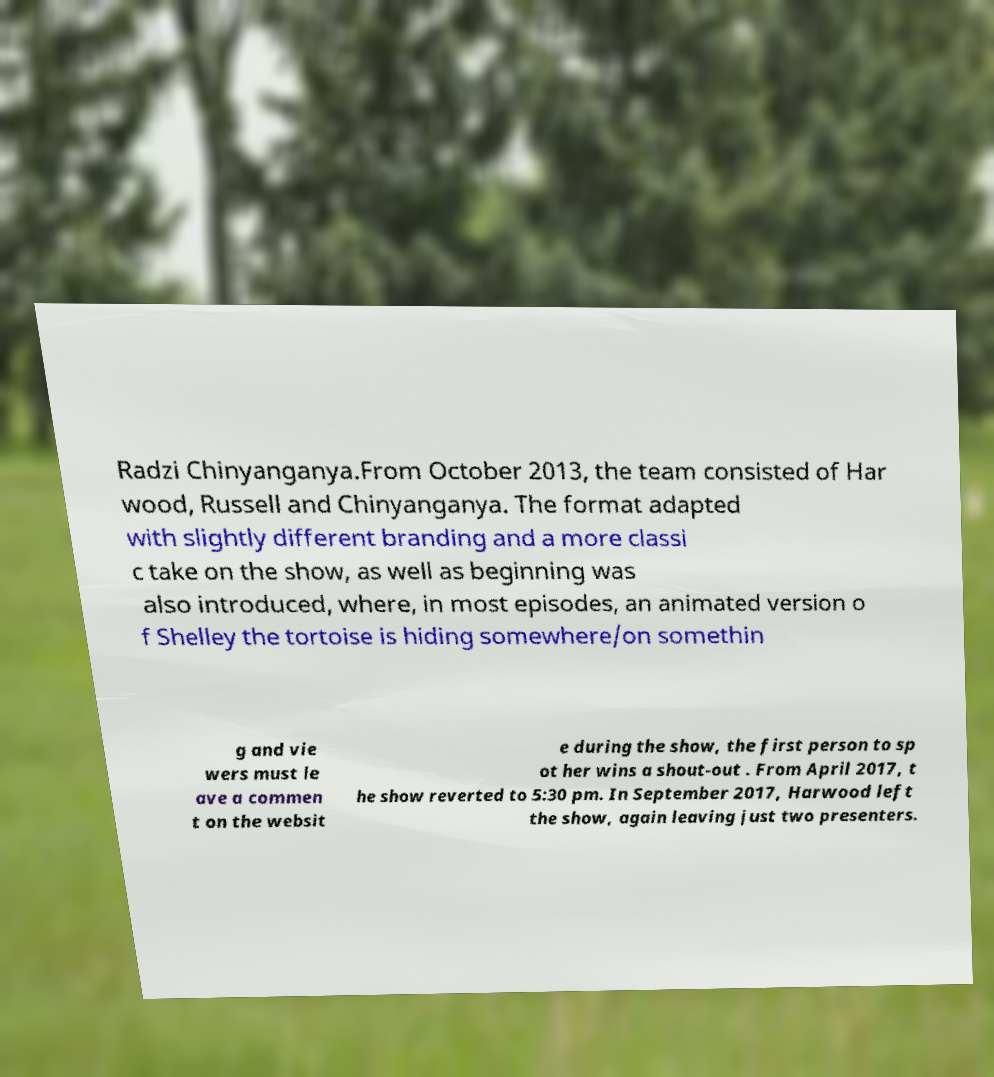Could you assist in decoding the text presented in this image and type it out clearly? Radzi Chinyanganya.From October 2013, the team consisted of Har wood, Russell and Chinyanganya. The format adapted with slightly different branding and a more classi c take on the show, as well as beginning was also introduced, where, in most episodes, an animated version o f Shelley the tortoise is hiding somewhere/on somethin g and vie wers must le ave a commen t on the websit e during the show, the first person to sp ot her wins a shout-out . From April 2017, t he show reverted to 5:30 pm. In September 2017, Harwood left the show, again leaving just two presenters. 